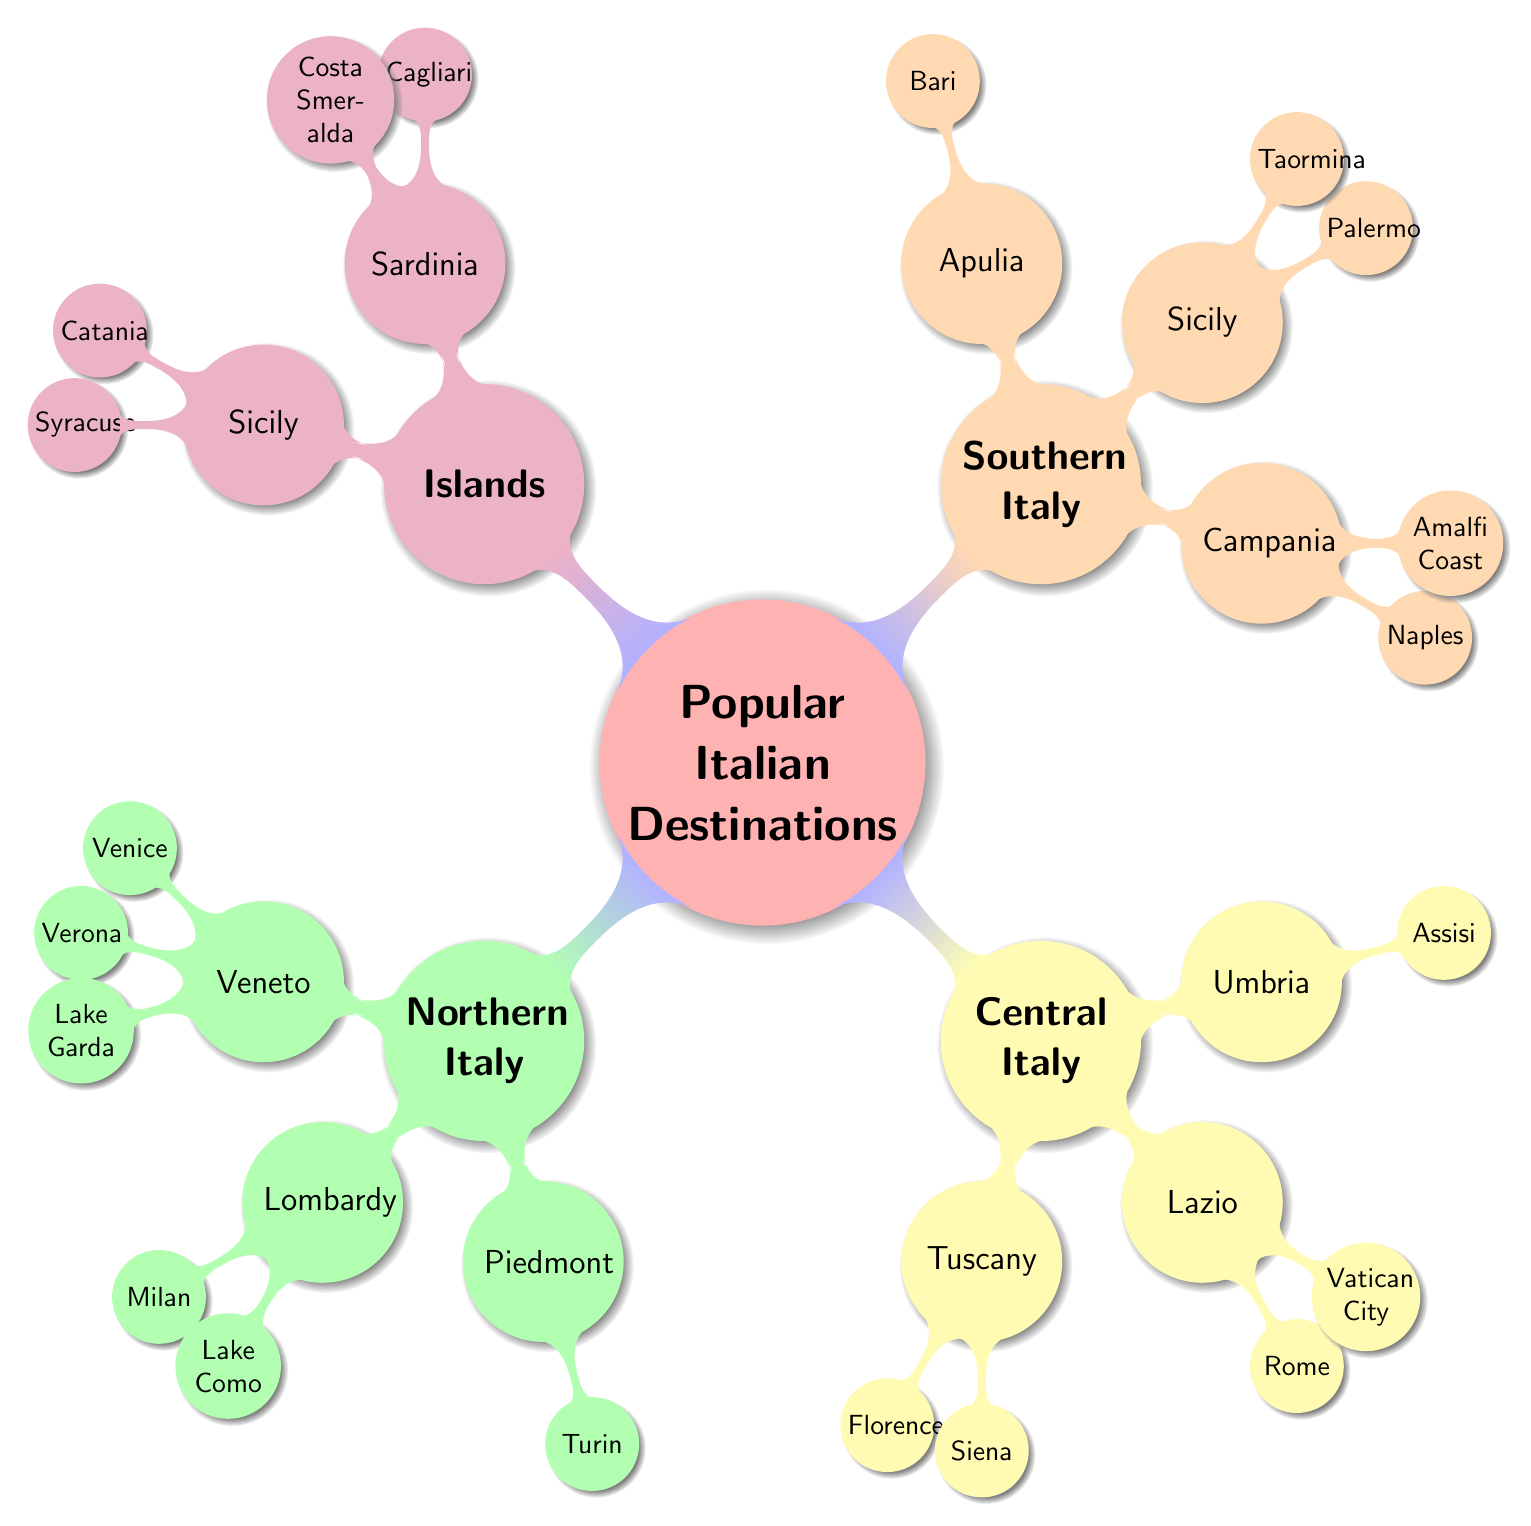What are three destinations in Northern Italy? From the diagram, under the "Northern Italy" node, the sub-nodes like "Veneto," "Lombardy," and "Piedmont" each list destinations. Selecting one from each region gives Venice, Milan, and Turin as three destinations.
Answer: Venice, Milan, Turin How many regions are listed in Central Italy? The "Central Italy" node breaks down into three sub-nodes: "Tuscany," "Lazio," and "Umbria." Counting these gives us a total of three regions.
Answer: 3 Which region includes the destination Pompeii? Pompeii is listed under "Campania," which is a sub-node of "Southern Italy." Therefore, the region containing Pompeii is Southern Italy.
Answer: Southern Italy What is the color used for the Islands section? The "Islands" section is indicated by the purple color in the mind map. This can be seen from the diagram's color coding.
Answer: Purple Which two destinations are from the same region in the diagram? For example, Taormina and Palermo are both listed under the "Sicily" node, indicating they are from the same region. To find pairs, we can see that they share the same parent node of "Islands."
Answer: Taormina, Palermo Name the destination located near Lake Como. Under the "Lombardy" section, "Lake Como" is mentioned as one of the destinations. This indicates that Lake Como is a specific location listed directly under Lombardy.
Answer: Lake Como Which region has the city of Venice? The diagram shows that Venice is a destination specifically listed under the "Veneto" region in the "Northern Italy" section. Thus, the region that has Venice is Veneto.
Answer: Veneto How many destinations are listed under Lazio? In the "Lazio" node, there are three destinations: "Rome," "Vatican City," and "Tivoli." Counting these gives a total of three destinations in Lazio.
Answer: 3 